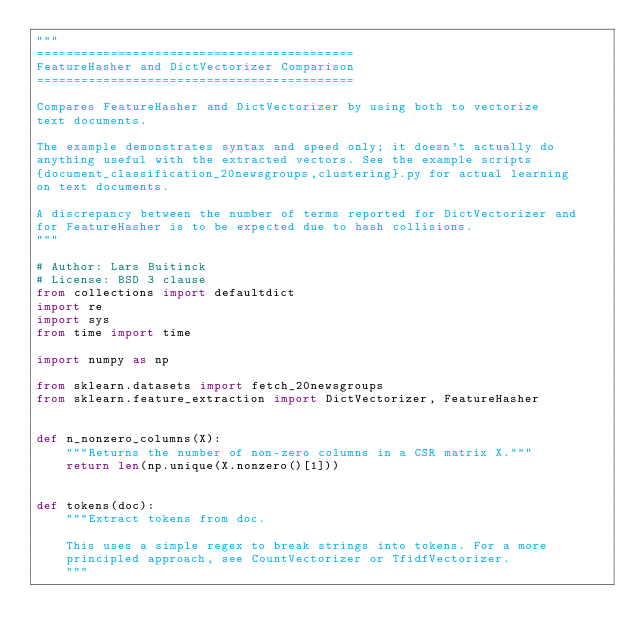Convert code to text. <code><loc_0><loc_0><loc_500><loc_500><_Python_>"""
===========================================
FeatureHasher and DictVectorizer Comparison
===========================================

Compares FeatureHasher and DictVectorizer by using both to vectorize
text documents.

The example demonstrates syntax and speed only; it doesn't actually do
anything useful with the extracted vectors. See the example scripts
{document_classification_20newsgroups,clustering}.py for actual learning
on text documents.

A discrepancy between the number of terms reported for DictVectorizer and
for FeatureHasher is to be expected due to hash collisions.
"""

# Author: Lars Buitinck
# License: BSD 3 clause
from collections import defaultdict
import re
import sys
from time import time

import numpy as np

from sklearn.datasets import fetch_20newsgroups
from sklearn.feature_extraction import DictVectorizer, FeatureHasher


def n_nonzero_columns(X):
    """Returns the number of non-zero columns in a CSR matrix X."""
    return len(np.unique(X.nonzero()[1]))


def tokens(doc):
    """Extract tokens from doc.

    This uses a simple regex to break strings into tokens. For a more
    principled approach, see CountVectorizer or TfidfVectorizer.
    """</code> 